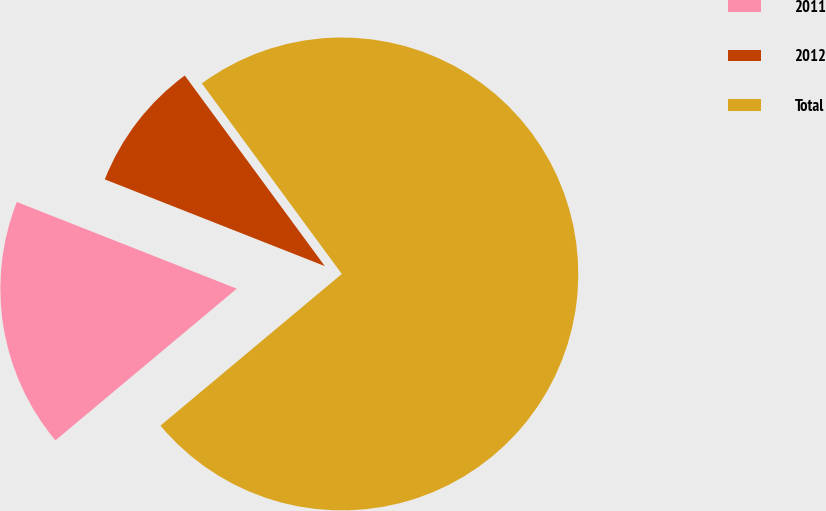<chart> <loc_0><loc_0><loc_500><loc_500><pie_chart><fcel>2011<fcel>2012<fcel>Total<nl><fcel>17.06%<fcel>8.94%<fcel>73.99%<nl></chart> 